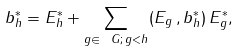Convert formula to latex. <formula><loc_0><loc_0><loc_500><loc_500>b ^ { * } _ { h } = E ^ { * } _ { h } + \sum _ { g \in \ G ; \, g < h } ( E _ { g } \, , b ^ { * } _ { h } ) \, E ^ { * } _ { g } ,</formula> 